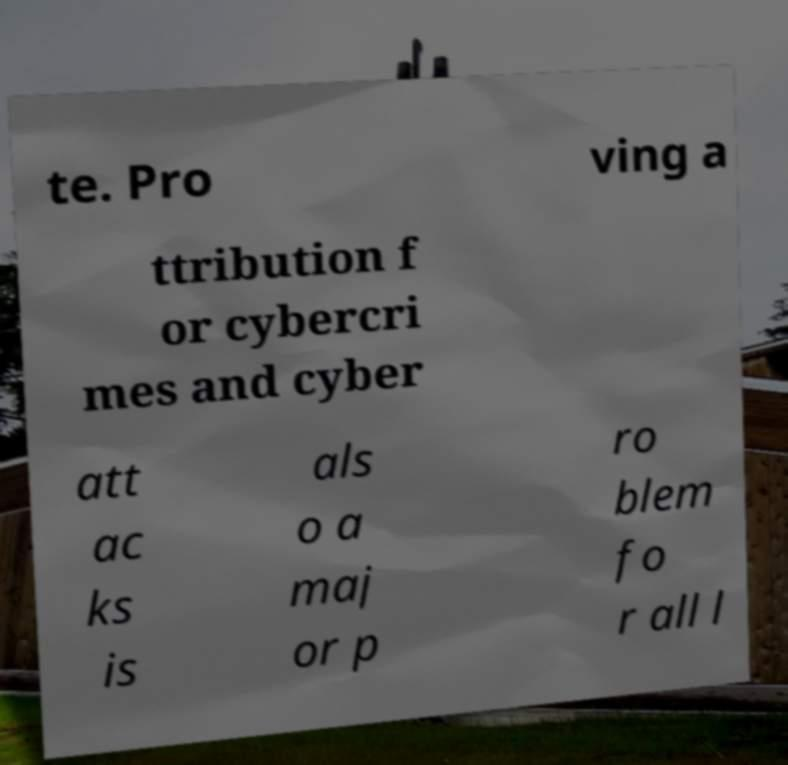Could you extract and type out the text from this image? te. Pro ving a ttribution f or cybercri mes and cyber att ac ks is als o a maj or p ro blem fo r all l 